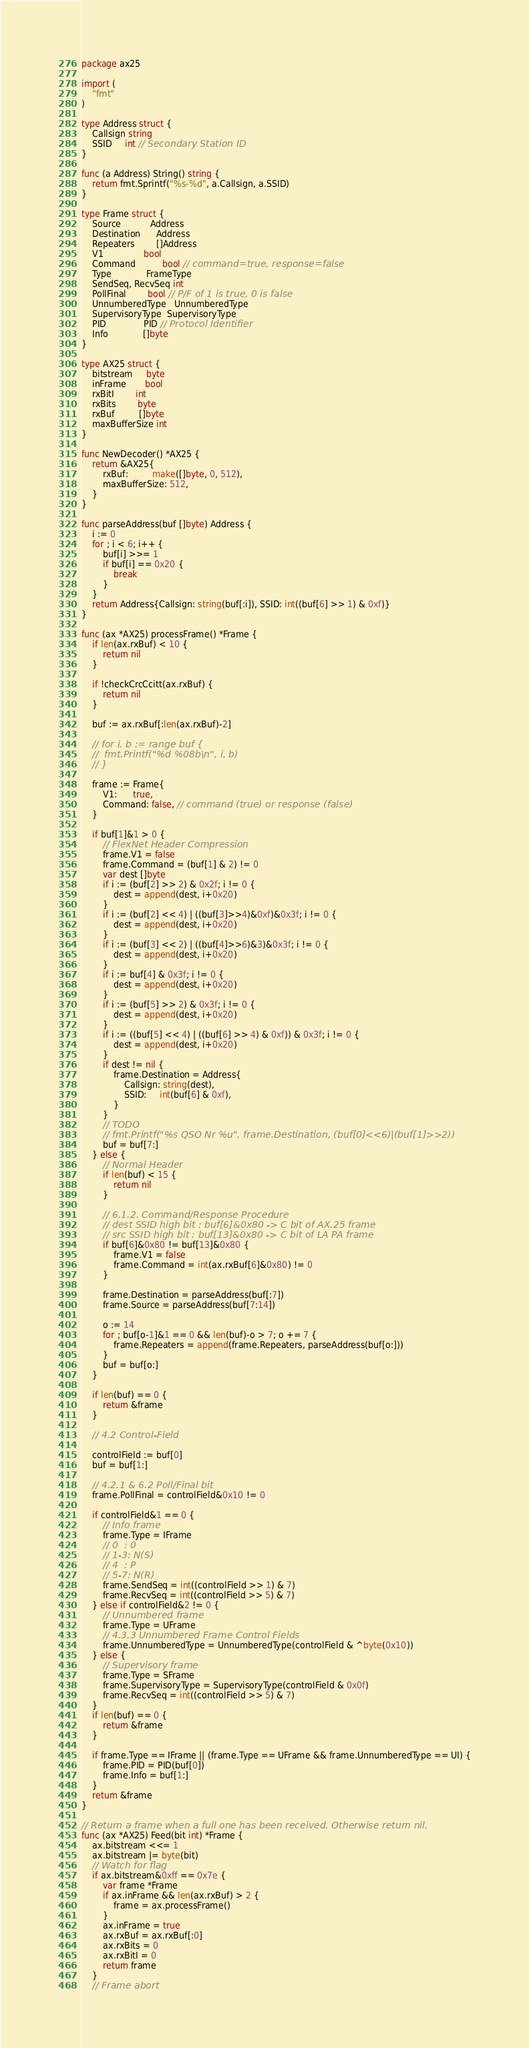<code> <loc_0><loc_0><loc_500><loc_500><_Go_>package ax25

import (
	"fmt"
)

type Address struct {
	Callsign string
	SSID     int // Secondary Station ID
}

func (a Address) String() string {
	return fmt.Sprintf("%s-%d", a.Callsign, a.SSID)
}

type Frame struct {
	Source           Address
	Destination      Address
	Repeaters        []Address
	V1               bool
	Command          bool // command=true, response=false
	Type             FrameType
	SendSeq, RecvSeq int
	PollFinal        bool // P/F of 1 is true, 0 is false
	UnnumberedType   UnnumberedType
	SupervisoryType  SupervisoryType
	PID              PID // Protocol Identifier
	Info             []byte
}

type AX25 struct {
	bitstream     byte
	inFrame       bool
	rxBitI        int
	rxBits        byte
	rxBuf         []byte
	maxBufferSize int
}

func NewDecoder() *AX25 {
	return &AX25{
		rxBuf:         make([]byte, 0, 512),
		maxBufferSize: 512,
	}
}

func parseAddress(buf []byte) Address {
	i := 0
	for ; i < 6; i++ {
		buf[i] >>= 1
		if buf[i] == 0x20 {
			break
		}
	}
	return Address{Callsign: string(buf[:i]), SSID: int((buf[6] >> 1) & 0xf)}
}

func (ax *AX25) processFrame() *Frame {
	if len(ax.rxBuf) < 10 {
		return nil
	}

	if !checkCrcCcitt(ax.rxBuf) {
		return nil
	}

	buf := ax.rxBuf[:len(ax.rxBuf)-2]

	// for i, b := range buf {
	// 	fmt.Printf("%d %08b\n", i, b)
	// }

	frame := Frame{
		V1:      true,
		Command: false, // command (true) or response (false)
	}

	if buf[1]&1 > 0 {
		// FlexNet Header Compression
		frame.V1 = false
		frame.Command = (buf[1] & 2) != 0
		var dest []byte
		if i := (buf[2] >> 2) & 0x2f; i != 0 {
			dest = append(dest, i+0x20)
		}
		if i := (buf[2] << 4) | ((buf[3]>>4)&0xf)&0x3f; i != 0 {
			dest = append(dest, i+0x20)
		}
		if i := (buf[3] << 2) | ((buf[4]>>6)&3)&0x3f; i != 0 {
			dest = append(dest, i+0x20)
		}
		if i := buf[4] & 0x3f; i != 0 {
			dest = append(dest, i+0x20)
		}
		if i := (buf[5] >> 2) & 0x3f; i != 0 {
			dest = append(dest, i+0x20)
		}
		if i := ((buf[5] << 4) | ((buf[6] >> 4) & 0xf)) & 0x3f; i != 0 {
			dest = append(dest, i+0x20)
		}
		if dest != nil {
			frame.Destination = Address{
				Callsign: string(dest),
				SSID:     int(buf[6] & 0xf),
			}
		}
		// TODO
		// fmt.Printf("%s QSO Nr %u", frame.Destination, (buf[0]<<6)|(buf[1]>>2))
		buf = buf[7:]
	} else {
		// Normal Header
		if len(buf) < 15 {
			return nil
		}

		// 6.1.2. Command/Response Procedure
		// dest SSID high bit : buf[6]&0x80 -> C bit of AX.25 frame
		// src SSID high bit : buf[13]&0x80 -> C bit of LA PA frame
		if buf[6]&0x80 != buf[13]&0x80 {
			frame.V1 = false
			frame.Command = int(ax.rxBuf[6]&0x80) != 0
		}

		frame.Destination = parseAddress(buf[:7])
		frame.Source = parseAddress(buf[7:14])

		o := 14
		for ; buf[o-1]&1 == 0 && len(buf)-o > 7; o += 7 {
			frame.Repeaters = append(frame.Repeaters, parseAddress(buf[o:]))
		}
		buf = buf[o:]
	}

	if len(buf) == 0 {
		return &frame
	}

	// 4.2 Control-Field

	controlField := buf[0]
	buf = buf[1:]

	// 4.2.1 & 6.2 Poll/Final bit
	frame.PollFinal = controlField&0x10 != 0

	if controlField&1 == 0 {
		// Info frame
		frame.Type = IFrame
		// 0  : 0
		// 1-3: N(S)
		// 4  : P
		// 5-7: N(R)
		frame.SendSeq = int((controlField >> 1) & 7)
		frame.RecvSeq = int((controlField >> 5) & 7)
	} else if controlField&2 != 0 {
		// Unnumbered frame
		frame.Type = UFrame
		// 4.3.3 Unnumbered Frame Control Fields
		frame.UnnumberedType = UnnumberedType(controlField & ^byte(0x10))
	} else {
		// Supervisory frame
		frame.Type = SFrame
		frame.SupervisoryType = SupervisoryType(controlField & 0x0f)
		frame.RecvSeq = int((controlField >> 5) & 7)
	}
	if len(buf) == 0 {
		return &frame
	}

	if frame.Type == IFrame || (frame.Type == UFrame && frame.UnnumberedType == UI) {
		frame.PID = PID(buf[0])
		frame.Info = buf[1:]
	}
	return &frame
}

// Return a frame when a full one has been received. Otherwise return nil.
func (ax *AX25) Feed(bit int) *Frame {
	ax.bitstream <<= 1
	ax.bitstream |= byte(bit)
	// Watch for flag
	if ax.bitstream&0xff == 0x7e {
		var frame *Frame
		if ax.inFrame && len(ax.rxBuf) > 2 {
			frame = ax.processFrame()
		}
		ax.inFrame = true
		ax.rxBuf = ax.rxBuf[:0]
		ax.rxBits = 0
		ax.rxBitI = 0
		return frame
	}
	// Frame abort</code> 